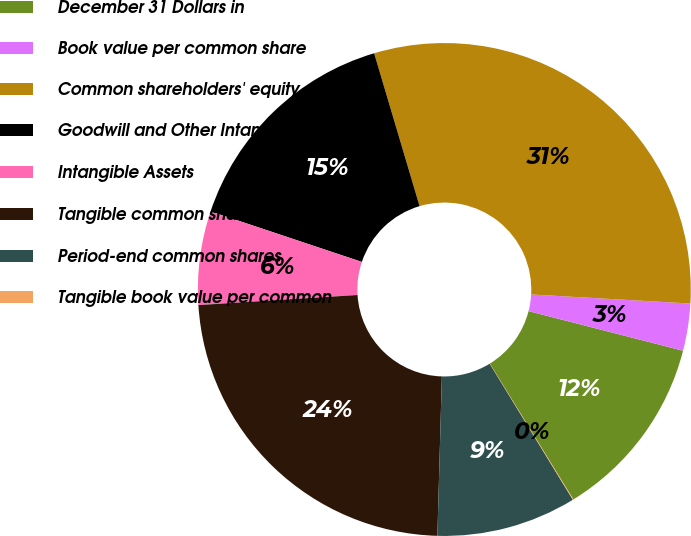<chart> <loc_0><loc_0><loc_500><loc_500><pie_chart><fcel>December 31 Dollars in<fcel>Book value per common share<fcel>Common shareholders' equity<fcel>Goodwill and Other Intangible<fcel>Intangible Assets<fcel>Tangible common shareholders'<fcel>Period-end common shares<fcel>Tangible book value per common<nl><fcel>12.23%<fcel>3.09%<fcel>30.5%<fcel>15.27%<fcel>6.14%<fcel>23.54%<fcel>9.18%<fcel>0.04%<nl></chart> 